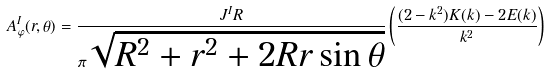Convert formula to latex. <formula><loc_0><loc_0><loc_500><loc_500>A _ { \varphi } ^ { I } ( r , \theta ) = \frac { J ^ { I } R } { \pi \sqrt { R ^ { 2 } + r ^ { 2 } + 2 R r \sin \theta } } \left ( \frac { ( 2 - k ^ { 2 } ) K ( k ) - 2 E ( k ) } { k ^ { 2 } } \right )</formula> 